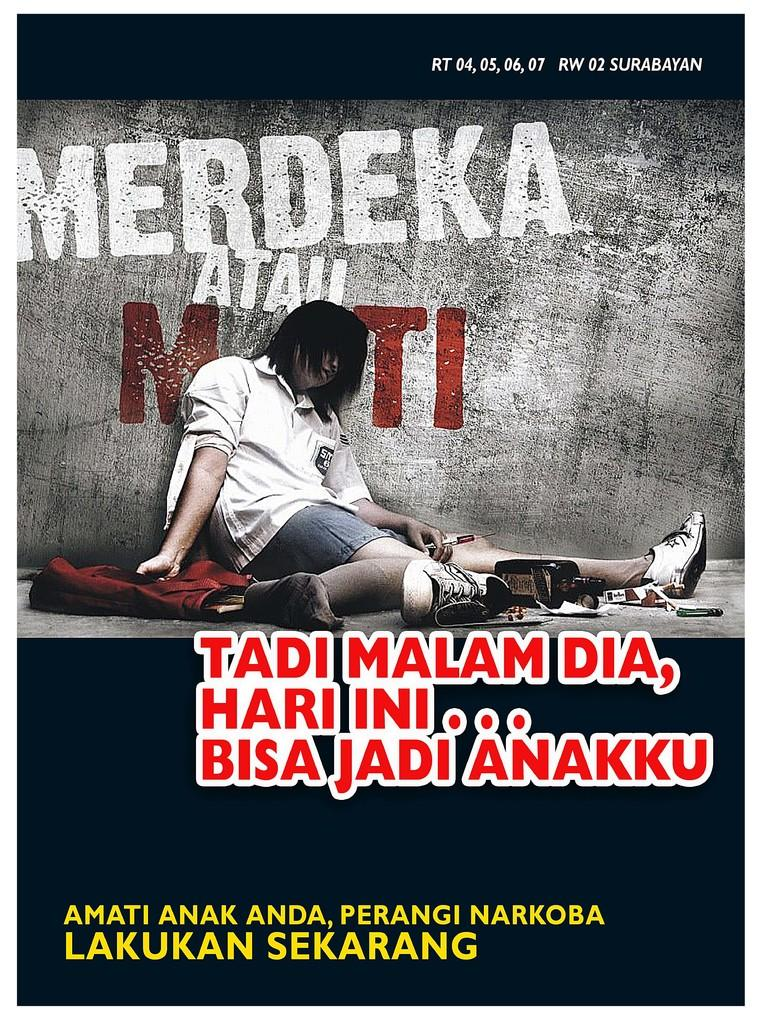What is the main subject of the poster in the image? The poster features a person sitting. What can be seen behind the person on the poster? There is a wall visible behind the person on the poster. What type of material is depicted on the poster? Cloth is depicted on the poster. Are there any words or letters on the poster? Yes, there is text on the poster. How many ladybugs can be seen crawling on the straw in the image? There is no straw or ladybugs present in the image. 